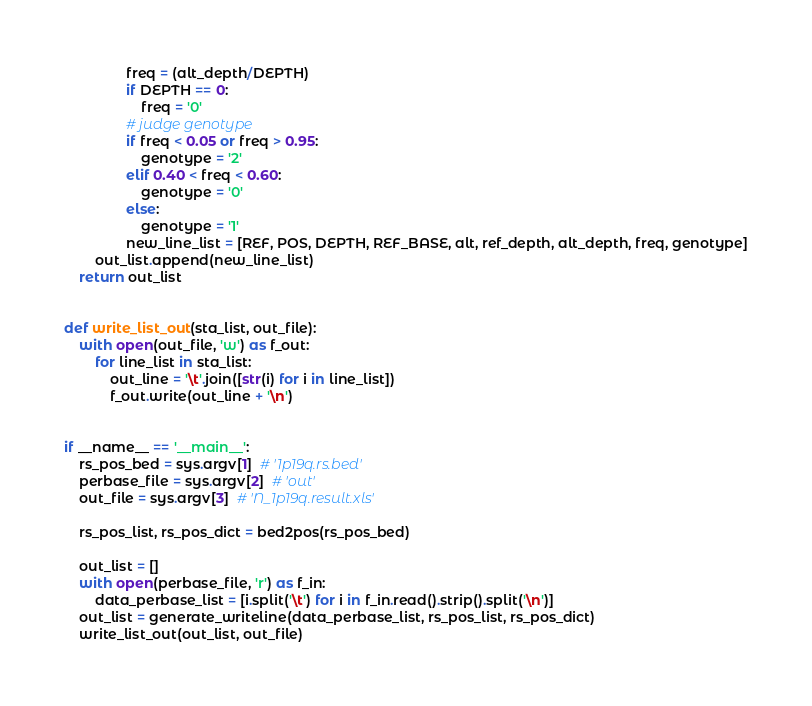<code> <loc_0><loc_0><loc_500><loc_500><_Python_>                freq = (alt_depth/DEPTH)
                if DEPTH == 0:
                    freq = '0'
                # judge genotype
                if freq < 0.05 or freq > 0.95:
                    genotype = '2'
                elif 0.40 < freq < 0.60:
                    genotype = '0'
                else:
                    genotype = '1'
                new_line_list = [REF, POS, DEPTH, REF_BASE, alt, ref_depth, alt_depth, freq, genotype]
        out_list.append(new_line_list)
    return out_list


def write_list_out(sta_list, out_file):
    with open(out_file, 'w') as f_out:
        for line_list in sta_list:
            out_line = '\t'.join([str(i) for i in line_list])
            f_out.write(out_line + '\n')


if __name__ == '__main__':
    rs_pos_bed = sys.argv[1]  # '1p19q.rs.bed'
    perbase_file = sys.argv[2]  # 'out'
    out_file = sys.argv[3]  # 'N_1p19q.result.xls'

    rs_pos_list, rs_pos_dict = bed2pos(rs_pos_bed)

    out_list = []
    with open(perbase_file, 'r') as f_in:
        data_perbase_list = [i.split('\t') for i in f_in.read().strip().split('\n')]
    out_list = generate_writeline(data_perbase_list, rs_pos_list, rs_pos_dict)
    write_list_out(out_list, out_file)

</code> 